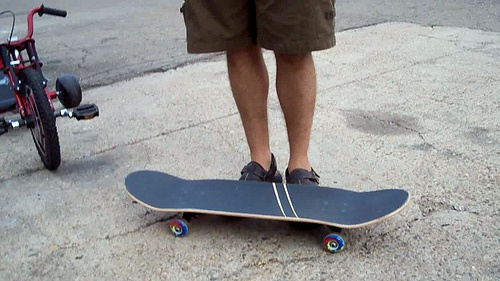Describe the objects in this image and their specific colors. I can see people in gray, black, maroon, and brown tones, skateboard in gray, blue, and black tones, and bicycle in gray, black, and darkgray tones in this image. 